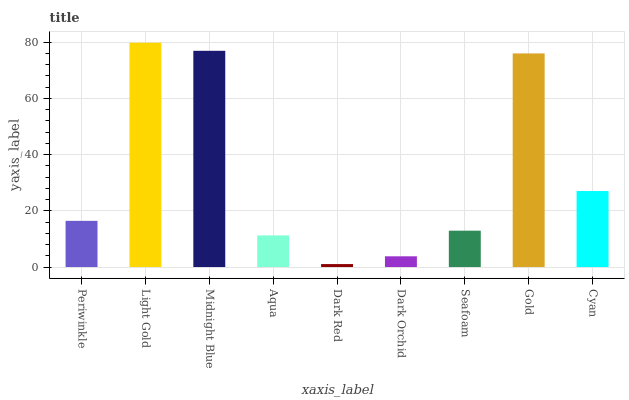Is Dark Red the minimum?
Answer yes or no. Yes. Is Light Gold the maximum?
Answer yes or no. Yes. Is Midnight Blue the minimum?
Answer yes or no. No. Is Midnight Blue the maximum?
Answer yes or no. No. Is Light Gold greater than Midnight Blue?
Answer yes or no. Yes. Is Midnight Blue less than Light Gold?
Answer yes or no. Yes. Is Midnight Blue greater than Light Gold?
Answer yes or no. No. Is Light Gold less than Midnight Blue?
Answer yes or no. No. Is Periwinkle the high median?
Answer yes or no. Yes. Is Periwinkle the low median?
Answer yes or no. Yes. Is Dark Orchid the high median?
Answer yes or no. No. Is Dark Red the low median?
Answer yes or no. No. 